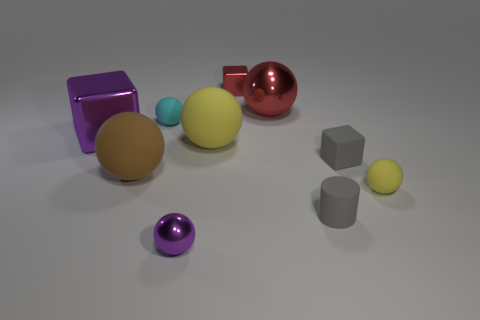Does the big cube have the same color as the tiny metallic ball?
Provide a succinct answer. Yes. What is the size of the red metallic thing that is the same shape as the small purple object?
Keep it short and to the point. Large. What number of large blue cylinders are made of the same material as the gray cube?
Keep it short and to the point. 0. Do the large thing behind the purple metal cube and the large cube have the same material?
Your answer should be compact. Yes. Are there the same number of big balls that are behind the large yellow object and big green metallic cubes?
Give a very brief answer. No. How big is the purple metallic cube?
Your answer should be compact. Large. There is a block that is the same color as the big metal sphere; what is its material?
Offer a very short reply. Metal. What number of large metallic things have the same color as the tiny metal block?
Make the answer very short. 1. Do the red shiny cube and the brown matte sphere have the same size?
Make the answer very short. No. What is the size of the purple object that is behind the purple metal object on the right side of the small cyan sphere?
Your answer should be very brief. Large. 